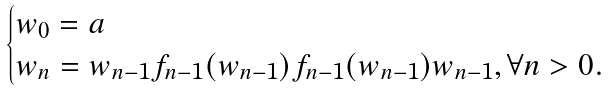Convert formula to latex. <formula><loc_0><loc_0><loc_500><loc_500>\begin{cases} w _ { 0 } = a \\ w _ { n } = w _ { n - 1 } f _ { n - 1 } ( w _ { n - 1 } ) f _ { n - 1 } ( w _ { n - 1 } ) w _ { n - 1 } , \forall n > 0 . \end{cases}</formula> 